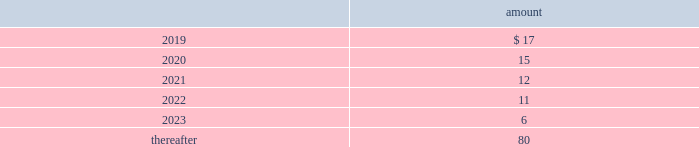The table provides the minimum annual future rental commitment under operating leases that have initial or remaining non-cancelable lease terms over the next five years and thereafter: .
The company has a series of agreements with various public entities ( the 201cpartners 201d ) to establish certain joint ventures , commonly referred to as 201cpublic-private partnerships . 201d under the public-private partnerships , the company constructed utility plant , financed by the company , and the partners constructed utility plant ( connected to the company 2019s property ) , financed by the partners .
The company agreed to transfer and convey some of its real and personal property to the partners in exchange for an equal principal amount of industrial development bonds ( 201cidbs 201d ) , issued by the partners under a state industrial development bond and commercial development act .
The company leased back the total facilities , including portions funded by both the company and the partners , under leases for a period of 40 years .
The leases related to the portion of the facilities funded by the company have required payments from the company to the partners that approximate the payments required by the terms of the idbs from the partners to the company ( as the holder of the idbs ) .
As the ownership of the portion of the facilities constructed by the company will revert back to the company at the end of the lease , the company has recorded these as capital leases .
The lease obligation and the receivable for the principal amount of the idbs are presented by the company on a net basis .
The carrying value of the facilities funded by the company recognized as a capital lease asset was $ 147 million and $ 150 million as of december 31 , 2018 and 2017 , respectively , which is presented in property , plant and equipment on the consolidated balance sheets .
The future payments under the lease obligations are equal to and offset by the payments receivable under the idbs .
As of december 31 , 2018 , the minimum annual future rental commitment under the operating leases for the portion of the facilities funded by the partners that have initial or remaining non-cancelable lease terms in excess of one year included in the preceding minimum annual rental commitments are $ 4 million in 2019 through 2023 , and $ 59 million thereafter .
Note 20 : segment information the company 2019s operating segments are comprised of the revenue-generating components of its businesses for which separate financial information is internally produced and regularly used by management to make operating decisions and assess performance .
The company operates its businesses primarily through one reportable segment , the regulated businesses segment .
The company also operates market-based businesses that provide a broad range of related and complementary water and wastewater services within non-reportable operating segments , collectively referred to as the market-based businesses .
The regulated businesses segment is the largest component of the company 2019s business and includes 20 subsidiaries that provide water and wastewater services to customers in 16 states .
The company 2019s primary market-based businesses include the homeowner services group , which provides warranty protection programs to residential and smaller commercial customers ; the military services group , which provides water and wastewater services to the u.s .
Government on military installations ; and keystone , which provides water transfer services for shale natural gas exploration and production companies. .
The carrying value of the facilities funded by the company recognized as a capital lease asset totaled how much in millions for december 31 , 2018 and 2017? 
Computations: (147 + 150)
Answer: 297.0. 